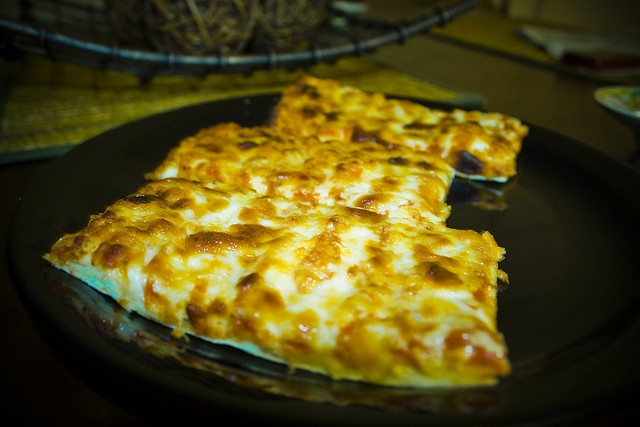Describe the objects in this image and their specific colors. I can see a pizza in black, gold, and olive tones in this image. 